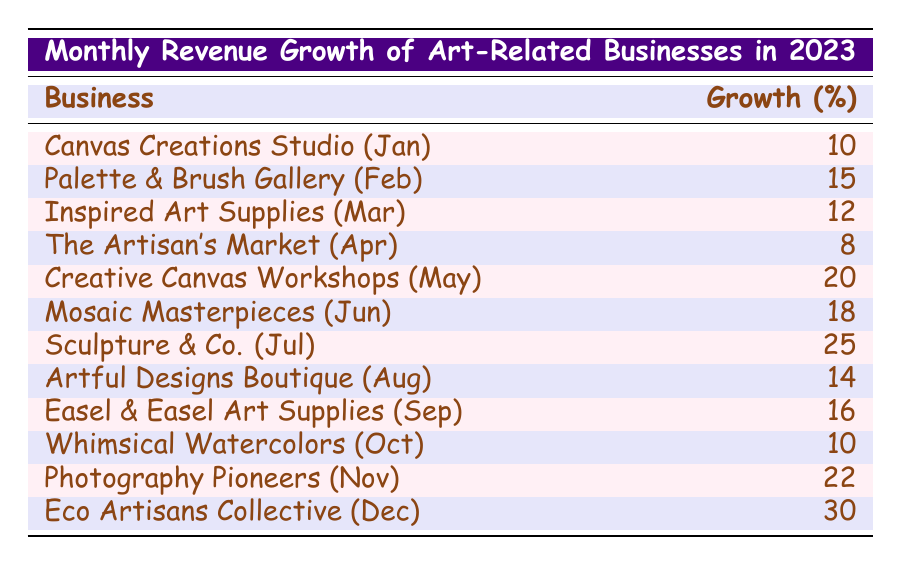What was the highest revenue growth percentage in December? Looking at the table, the entry for December is "Eco Artisans Collective" with a revenue growth percentage of 30. Since this is the only value for December, it is also the highest for that month.
Answer: 30 Which business had the lowest revenue growth percentage in April? In April, "The Artisan's Market" has a revenue growth percentage of 8, which is the only entry for that month, making it the lowest for April.
Answer: 8 What is the total revenue growth percentage for businesses from May to July? The revenue growth percentages for May (20), June (18), and July (25) are summed as follows: 20 + 18 + 25 = 63.
Answer: 63 Did "Canvas Creations Studio" have a higher revenue growth percentage than "Whimsical Watercolors"? "Canvas Creations Studio" had a revenue growth percentage of 10 while "Whimsical Watercolors" had a revenue growth of 10 as well. Therefore, they are equal, not higher.
Answer: No Which month had the highest revenue growth percentage and what was it? The table shows that December had the highest revenue growth percentage of 30, from "Eco Artisans Collective". Therefore, December is the month with highest growth.
Answer: December, 30 What was the average revenue growth percentage for the first quarter of the year (January to March)? For January, February, and March, the corresponding percentages are 10, 15, and 12. Adding them gives 10 + 15 + 12 = 37. There are 3 months, so the average is 37/3 = 12.33.
Answer: 12.33 Which business recorded a revenue growth percentage of 22 in November? The table states that the business "Photography Pioneers" recorded a revenue growth percentage of 22 in November. This can be directly observed from the table entry for that month.
Answer: Photography Pioneers Is the revenue growth percentage in August greater than or equal to 14? The entry for August shows a revenue growth percentage of 14, which is equal to 14. Thus, the statement is true.
Answer: Yes 